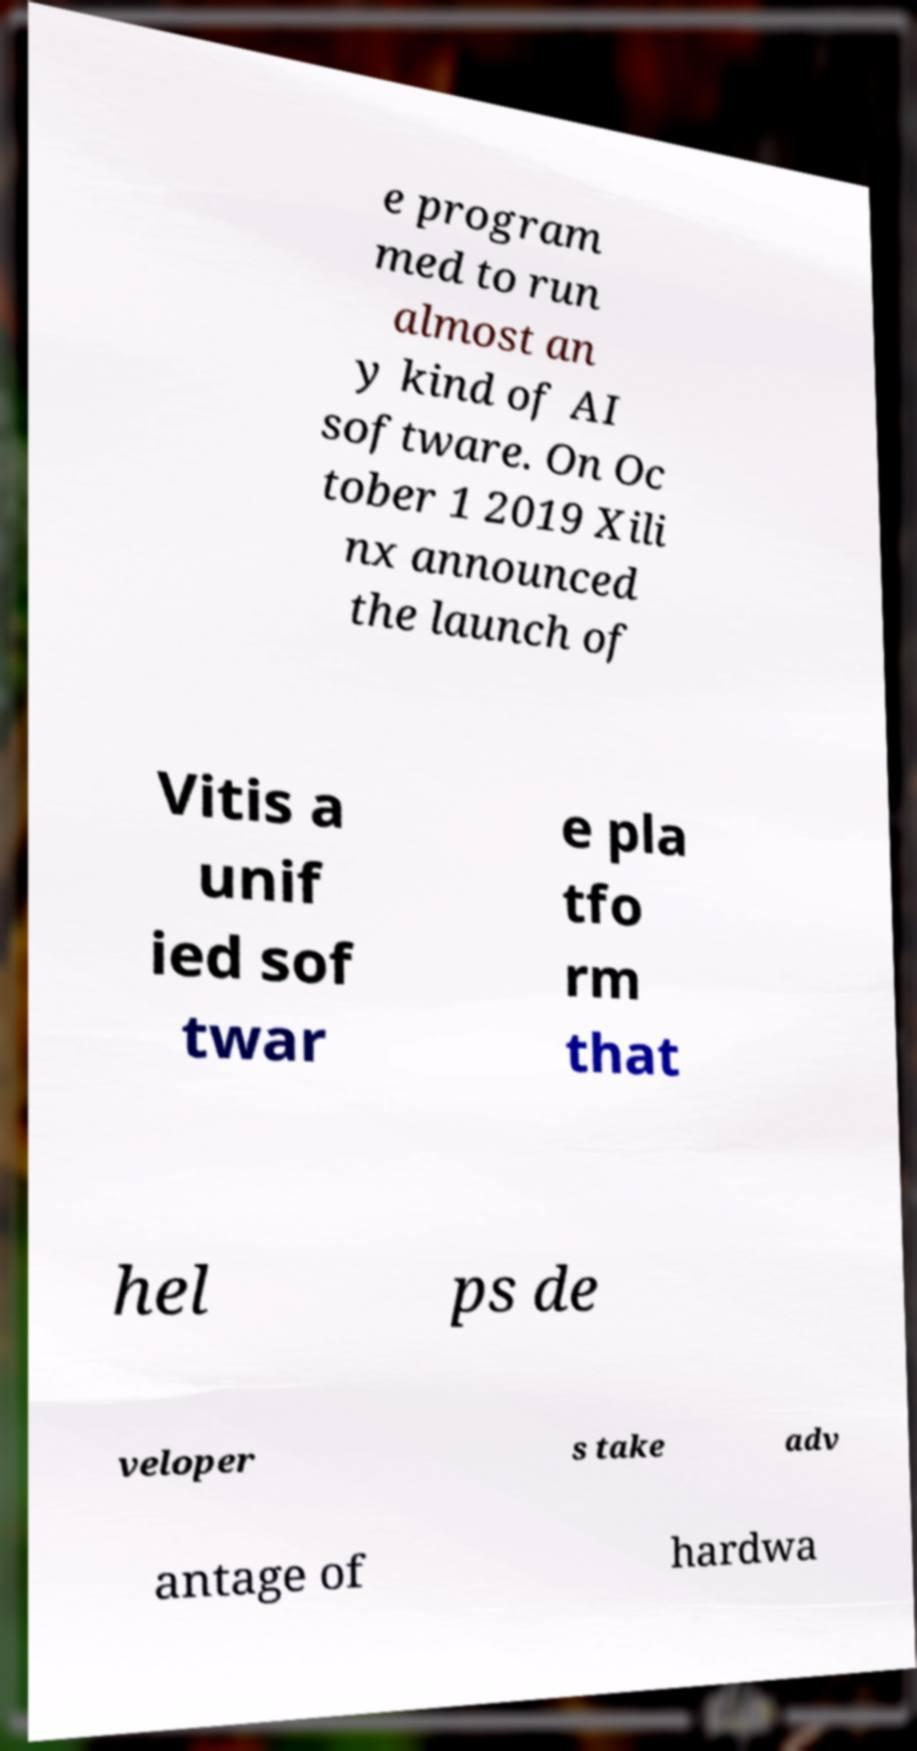I need the written content from this picture converted into text. Can you do that? e program med to run almost an y kind of AI software. On Oc tober 1 2019 Xili nx announced the launch of Vitis a unif ied sof twar e pla tfo rm that hel ps de veloper s take adv antage of hardwa 